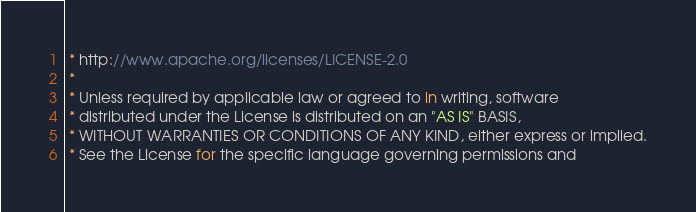Convert code to text. <code><loc_0><loc_0><loc_500><loc_500><_TypeScript_> * http://www.apache.org/licenses/LICENSE-2.0
 *
 * Unless required by applicable law or agreed to in writing, software
 * distributed under the License is distributed on an "AS IS" BASIS,
 * WITHOUT WARRANTIES OR CONDITIONS OF ANY KIND, either express or implied.
 * See the License for the specific language governing permissions and</code> 